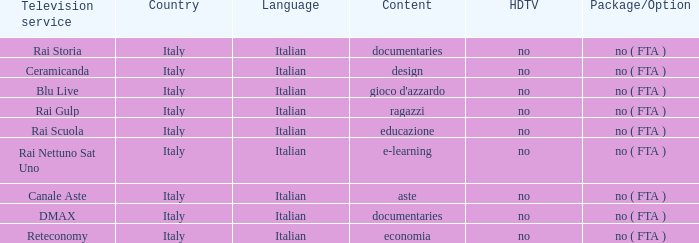What is the HDTV when documentaries are the content? No, no. Parse the full table. {'header': ['Television service', 'Country', 'Language', 'Content', 'HDTV', 'Package/Option'], 'rows': [['Rai Storia', 'Italy', 'Italian', 'documentaries', 'no', 'no ( FTA )'], ['Ceramicanda', 'Italy', 'Italian', 'design', 'no', 'no ( FTA )'], ['Blu Live', 'Italy', 'Italian', "gioco d'azzardo", 'no', 'no ( FTA )'], ['Rai Gulp', 'Italy', 'Italian', 'ragazzi', 'no', 'no ( FTA )'], ['Rai Scuola', 'Italy', 'Italian', 'educazione', 'no', 'no ( FTA )'], ['Rai Nettuno Sat Uno', 'Italy', 'Italian', 'e-learning', 'no', 'no ( FTA )'], ['Canale Aste', 'Italy', 'Italian', 'aste', 'no', 'no ( FTA )'], ['DMAX', 'Italy', 'Italian', 'documentaries', 'no', 'no ( FTA )'], ['Reteconomy', 'Italy', 'Italian', 'economia', 'no', 'no ( FTA )']]} 